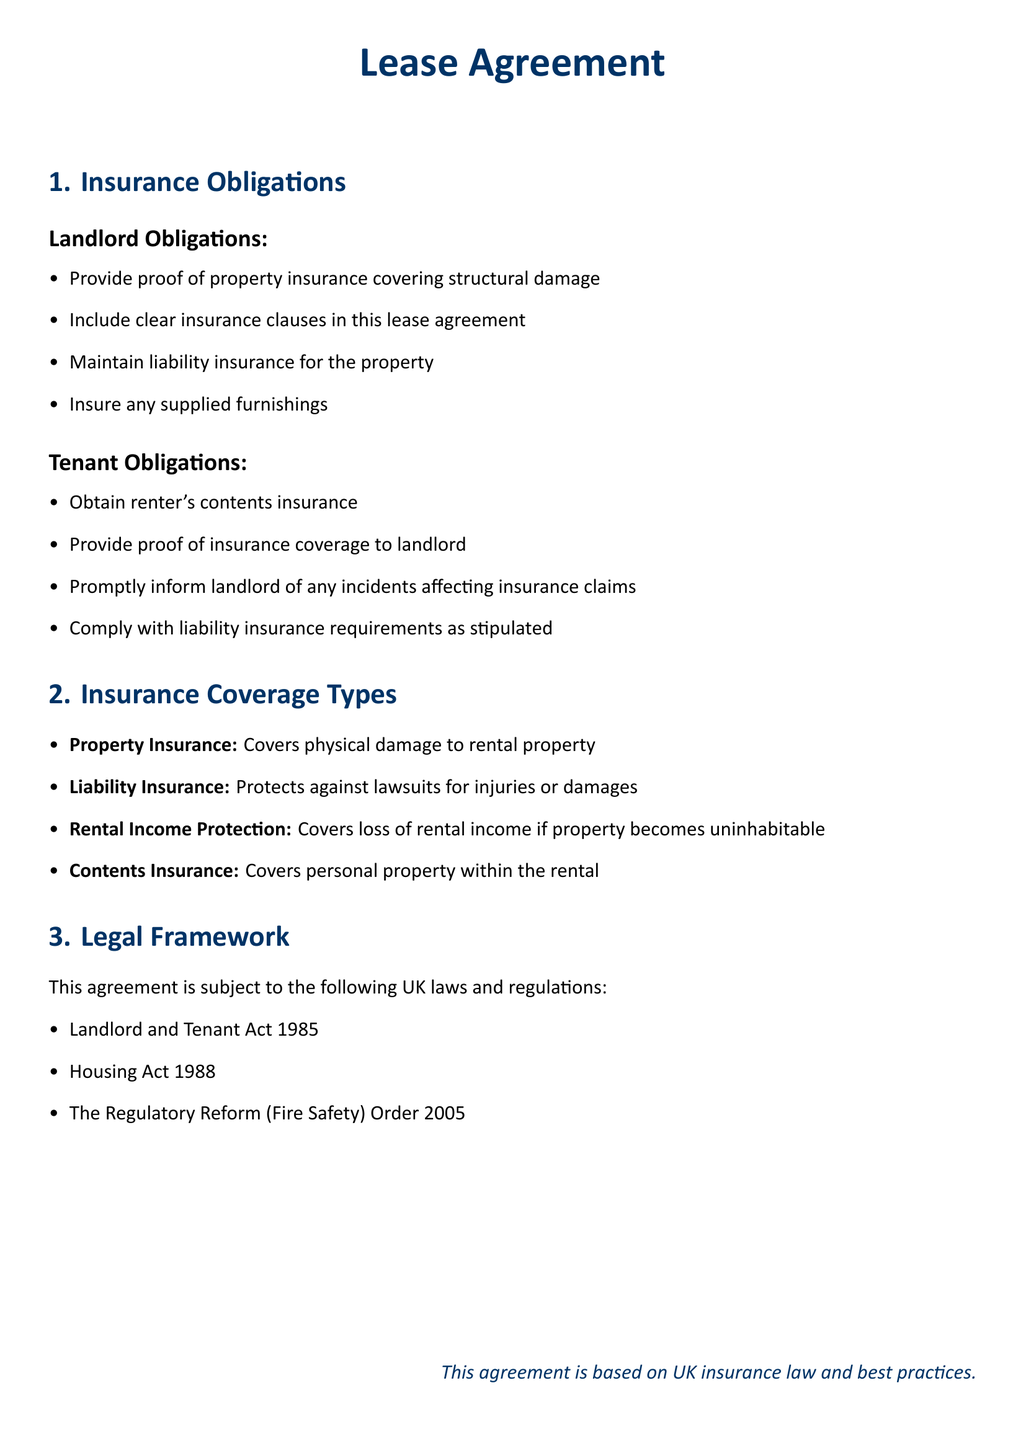What are the landlord's obligations? The landlord's obligations include providing proof of property insurance covering structural damage, including clear insurance clauses in this lease agreement, maintaining liability insurance for the property, and insuring any supplied furnishings.
Answer: Proof of property insurance, clear insurance clauses, maintain liability insurance, insure supplied furnishings What is required of the tenant regarding insurance? The tenant is required to obtain renter's contents insurance, provide proof of insurance coverage to the landlord, promptly inform the landlord of any incidents affecting insurance claims, and comply with liability insurance requirements.
Answer: Obtain renter's contents insurance, provide proof to landlord, inform landlord of incidents, comply with liability requirements What type of insurance protects against lawsuits? Liability insurance protects against lawsuits for injuries or damages.
Answer: Liability insurance Which act is referenced in the legal framework? The Landlord and Tenant Act 1985 is referenced in the legal framework of the agreement.
Answer: Landlord and Tenant Act 1985 What does property insurance cover? Property insurance covers physical damage to rental property.
Answer: Physical damage to rental property What type of insurance must the tenant provide proof of? The tenant must provide proof of renter's contents insurance.
Answer: Renter's contents insurance How many types of insurance coverage are listed? There are four types of insurance coverage listed in the document.
Answer: Four Which order relates to fire safety in the legal framework? The Regulatory Reform (Fire Safety) Order 2005 relates to fire safety in the legal framework.
Answer: Regulatory Reform (Fire Safety) Order 2005 